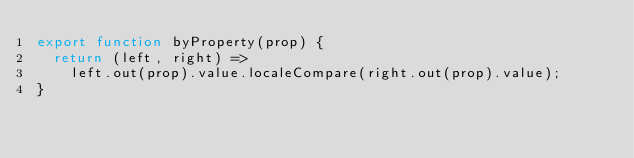Convert code to text. <code><loc_0><loc_0><loc_500><loc_500><_JavaScript_>export function byProperty(prop) {
  return (left, right) =>
    left.out(prop).value.localeCompare(right.out(prop).value);
}
</code> 